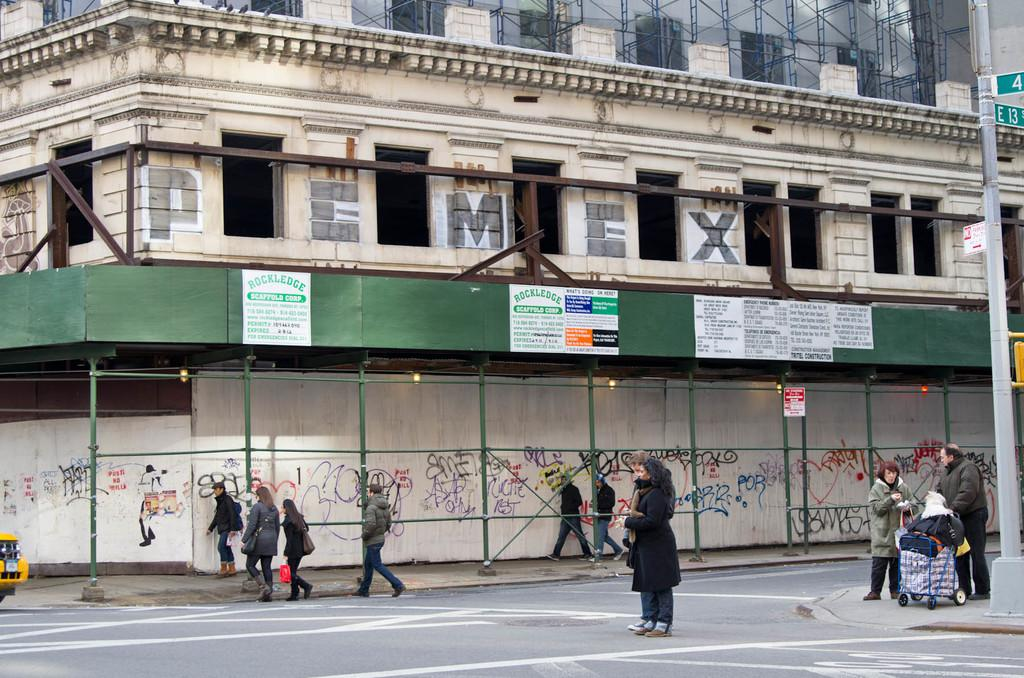Provide a one-sentence caption for the provided image. The name Pemex is painted on the side of a building. 